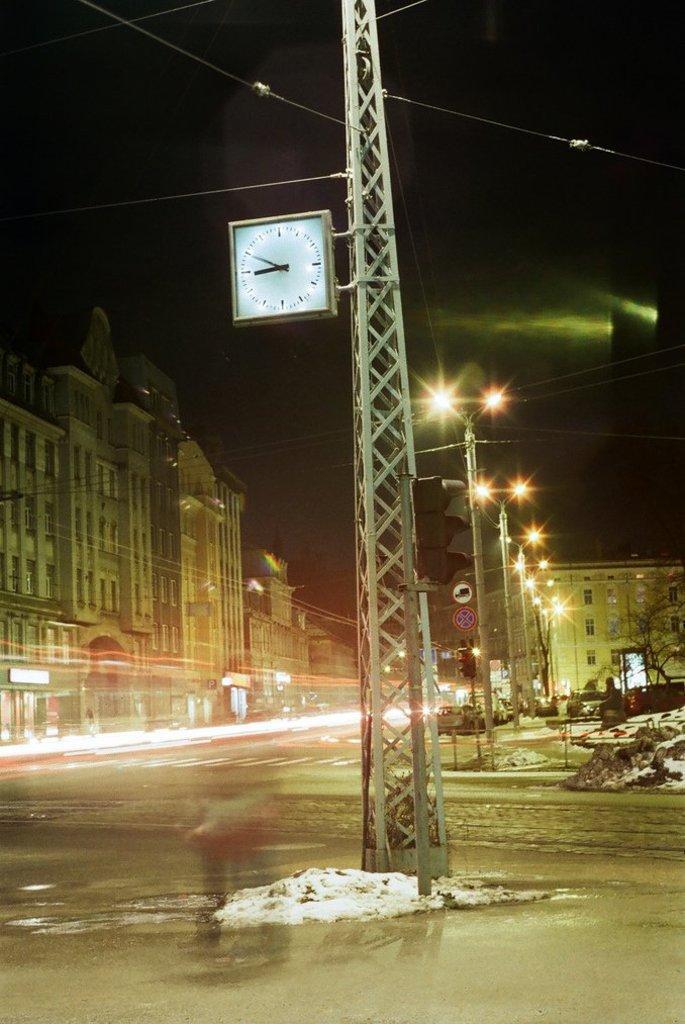What is the main structure in the image? There is a metal tower in the image. What is attached to the metal tower? The metal tower has a square clock on it. What can be seen in the background of the image? There is a street visible in the image, and there are buildings on the left side of the image. What else can be seen on the street? There are lights poles on the street. How many dogs are visible in the image, and what are they doing? There are no dogs present in the image. What type of adjustment is being made to the clock in the image? There is no adjustment being made to the clock in the image; it is simply displayed on the metal tower. 